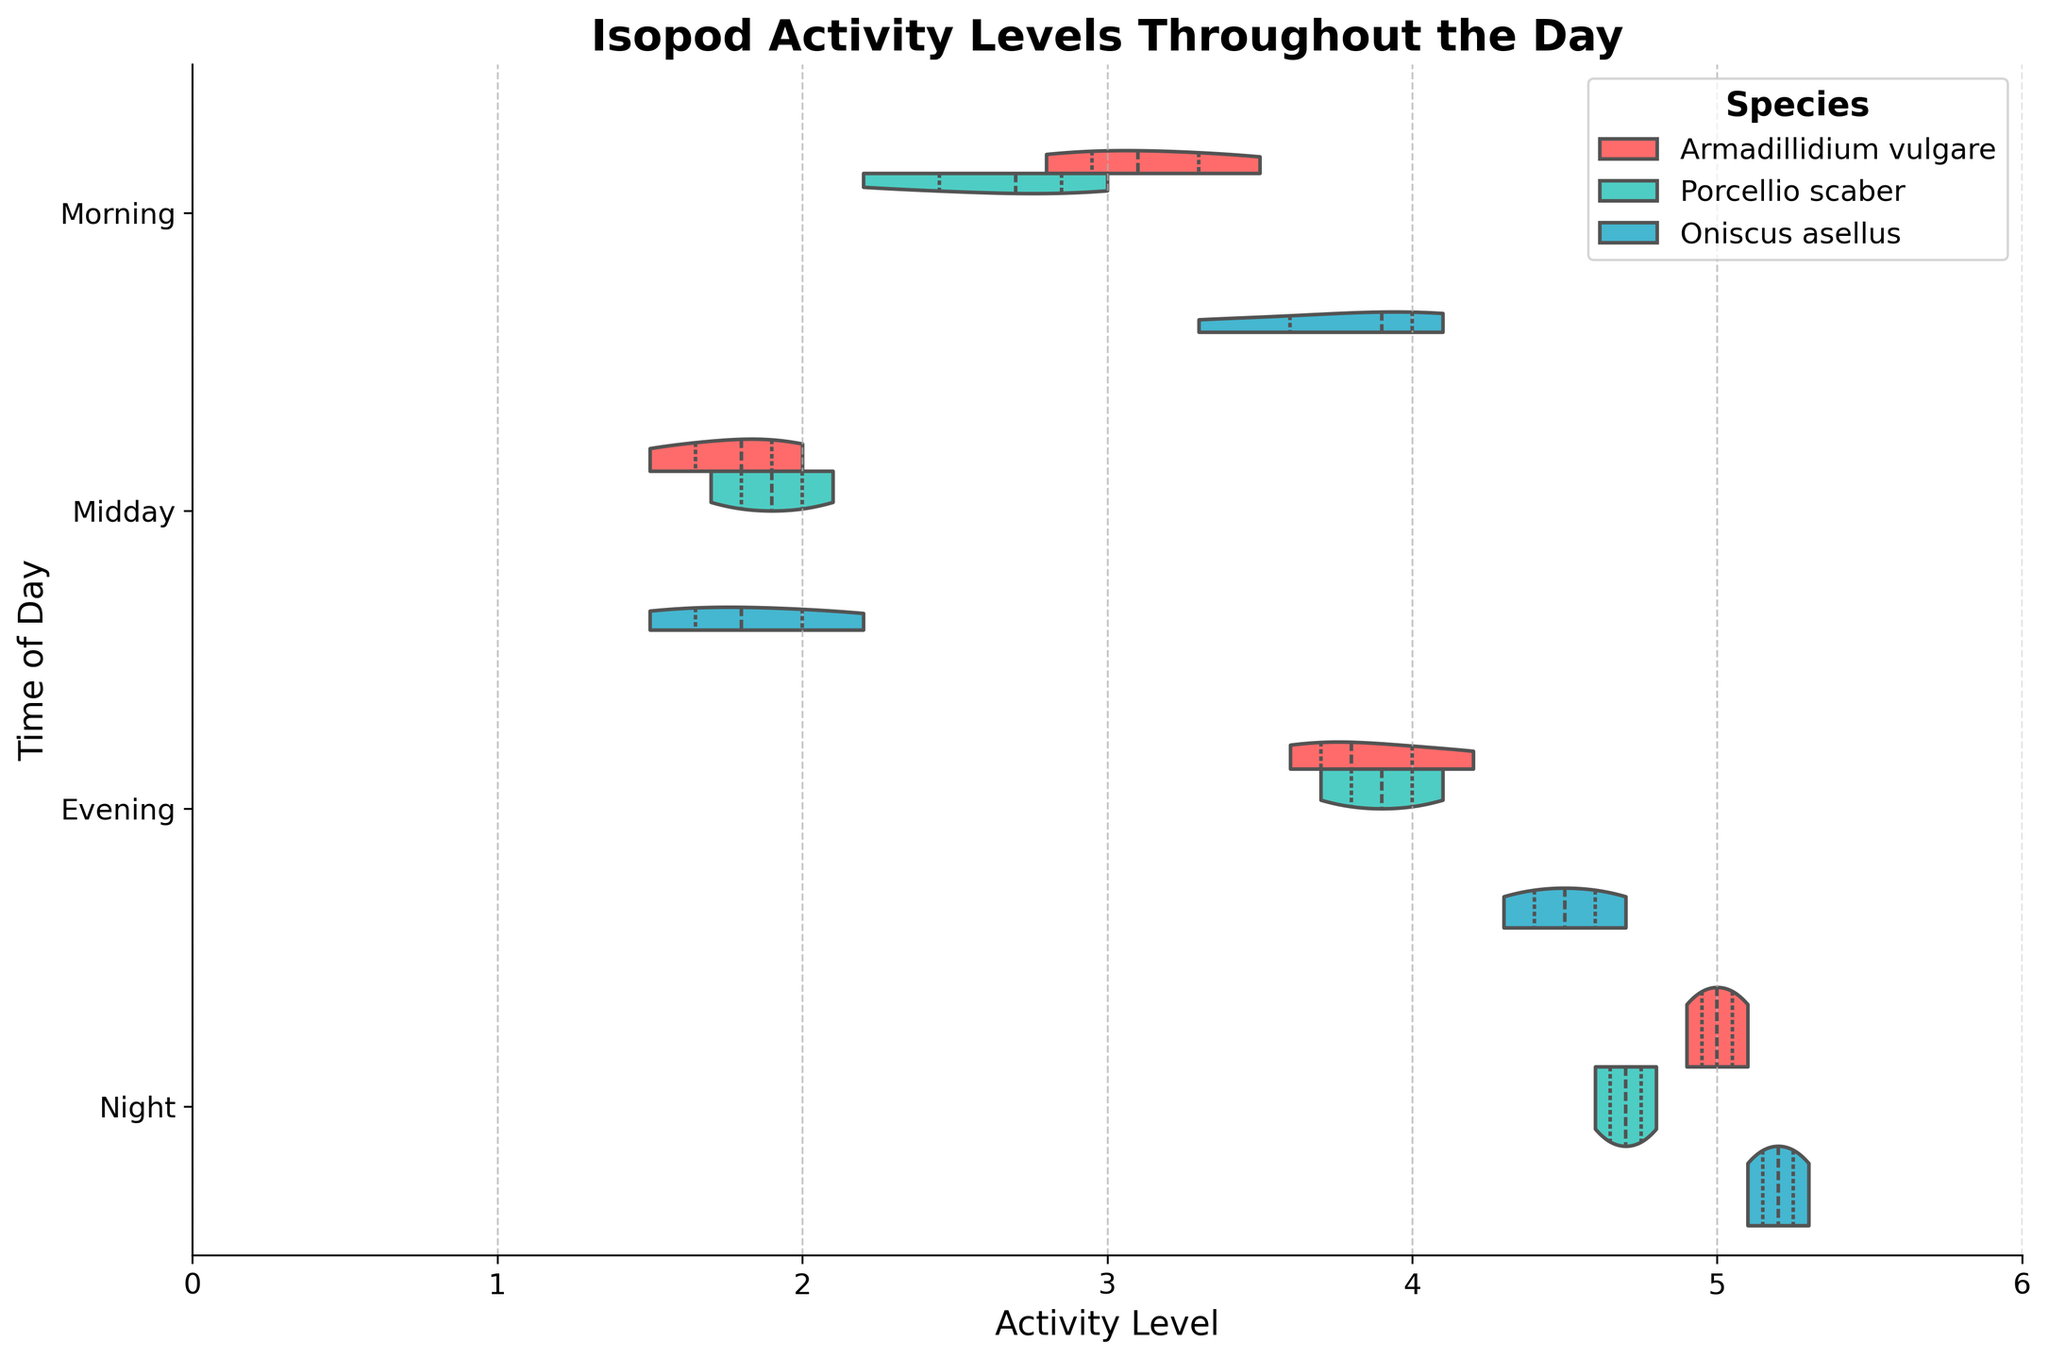What is the title of the chart? The title of the chart is typically displayed at the top and indicates what the chart is about. Here, it is shown in bold and large font.
Answer: Isopod Activity Levels Throughout the Day Which species has the highest activity level during the night? From the chart, we identify the violins corresponding to different species and their activity levels during the night. The highest point in the violin plot for "Oniscus asellus" is slightly higher than for the other species.
Answer: Oniscus asellus During which time of day does "Armadillidium vulgare" show the lowest activity levels? By examining the violins for "Armadillidium vulgare" across different times, we see that the midday violin is shifted towards lower activity levels compared to the others.
Answer: Midday Which species shows the most variability in activity levels during the evening? Variability can be observed by the width and spread of the violin plots. The plot for "Oniscus asellus" during the evening is wider and has a greater spread compared to "Porcellio scaber" and "Armadillidium vulgare". This indicates more variability.
Answer: Oniscus asellus Compare the median activity levels of "Porcellio scaber" between morning and evening. Which is higher? The median is represented by the line inside the violin plots. By comparing "Porcellio scaber" in morning and evening, we find that the median line in the evening is higher.
Answer: Evening What is the range of activity levels for "Oniscus asellus" during the morning? The range is determined by the lowest and highest points of the violin. For "Oniscus asellus" during the morning, the activity levels range approximately from 3.3 to 4.1.
Answer: 3.3 to 4.1 Which time of day shows the highest average activity level across all species? By comparing the centers of all violin plots, the night violins are centered at higher activity levels compared to morning, midday, and evening.
Answer: Night Do "Porcellio scaber" and "Armadillidium vulgare" have overlapping activity levels during the evening? An overlap occurs if the violin plots for the two species intersect horizontally. During the evening, the violins for "Porcellio scaber" and "Armadillidium vulgare" do intersect, indicating overlapping activity levels.
Answer: Yes How does the activity level distribution of "Armadillidium vulgare" change from morning to night? The violin plots indicate how the activity levels shift. For "Armadillidium vulgare", the activity level distribution shifts higher from morning through night, with the night having the highest distribution.
Answer: It increases In which time of day is the activity level of "Armadillidium vulgare" more concentrated, midday or evening? Concentration can be inferred from the narrowness of the violin plot. The violin for "Armadillidium vulgare" during midday is narrower than that during the evening, indicating more concentration.
Answer: Midday 